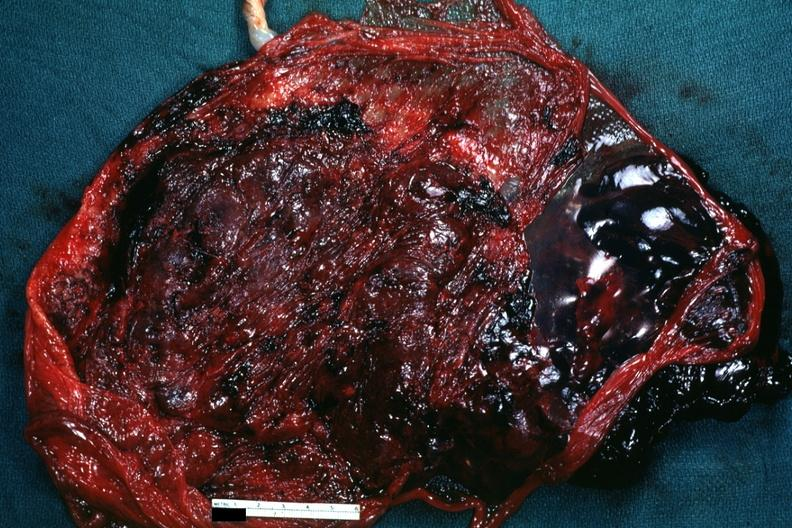what does this image show?
Answer the question using a single word or phrase. Maternal surface with blood clot 